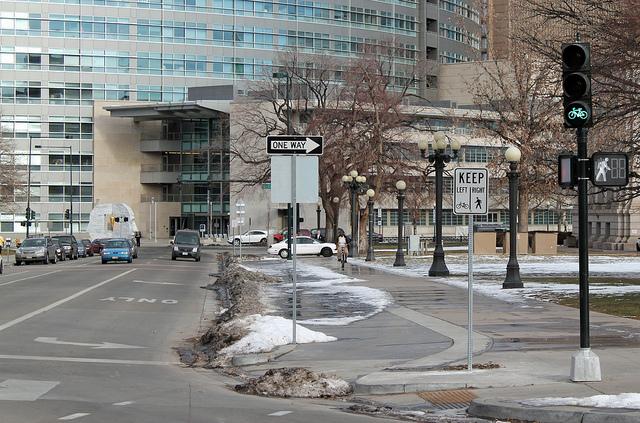What way are you allowed to go on the road?
Quick response, please. Right. Is the light red, yellow or green?
Short answer required. Green. What color is the traffic light?
Quick response, please. Green. Is the building tall?
Keep it brief. Yes. 